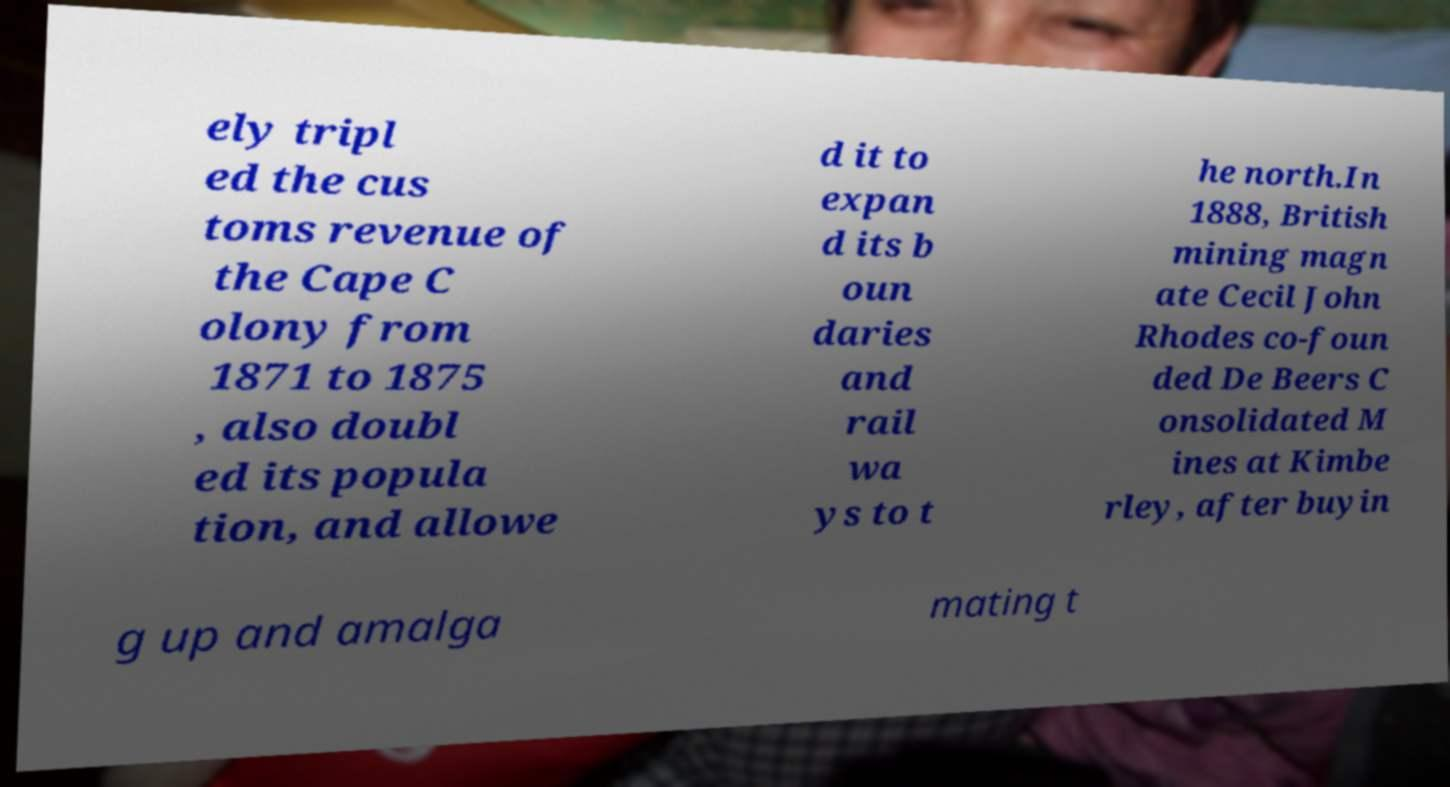What messages or text are displayed in this image? I need them in a readable, typed format. ely tripl ed the cus toms revenue of the Cape C olony from 1871 to 1875 , also doubl ed its popula tion, and allowe d it to expan d its b oun daries and rail wa ys to t he north.In 1888, British mining magn ate Cecil John Rhodes co-foun ded De Beers C onsolidated M ines at Kimbe rley, after buyin g up and amalga mating t 